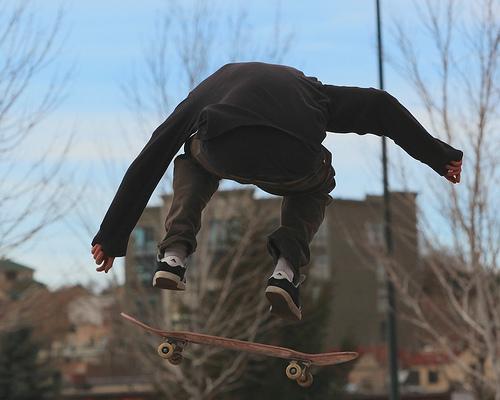How many skateboards are there?
Give a very brief answer. 1. How many trees are on the left of the person?
Give a very brief answer. 1. 